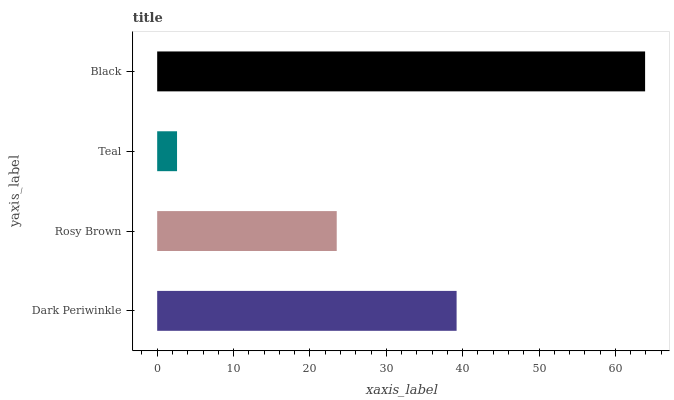Is Teal the minimum?
Answer yes or no. Yes. Is Black the maximum?
Answer yes or no. Yes. Is Rosy Brown the minimum?
Answer yes or no. No. Is Rosy Brown the maximum?
Answer yes or no. No. Is Dark Periwinkle greater than Rosy Brown?
Answer yes or no. Yes. Is Rosy Brown less than Dark Periwinkle?
Answer yes or no. Yes. Is Rosy Brown greater than Dark Periwinkle?
Answer yes or no. No. Is Dark Periwinkle less than Rosy Brown?
Answer yes or no. No. Is Dark Periwinkle the high median?
Answer yes or no. Yes. Is Rosy Brown the low median?
Answer yes or no. Yes. Is Teal the high median?
Answer yes or no. No. Is Teal the low median?
Answer yes or no. No. 